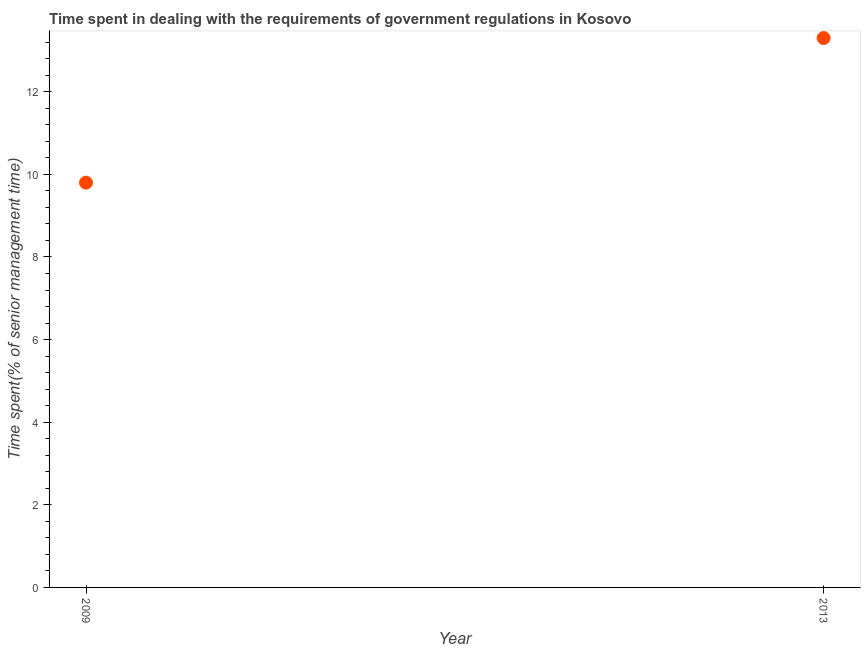Across all years, what is the minimum time spent in dealing with government regulations?
Keep it short and to the point. 9.8. In which year was the time spent in dealing with government regulations maximum?
Provide a succinct answer. 2013. What is the sum of the time spent in dealing with government regulations?
Your response must be concise. 23.1. What is the difference between the time spent in dealing with government regulations in 2009 and 2013?
Ensure brevity in your answer.  -3.5. What is the average time spent in dealing with government regulations per year?
Provide a short and direct response. 11.55. What is the median time spent in dealing with government regulations?
Provide a short and direct response. 11.55. What is the ratio of the time spent in dealing with government regulations in 2009 to that in 2013?
Ensure brevity in your answer.  0.74. Is the time spent in dealing with government regulations in 2009 less than that in 2013?
Offer a very short reply. Yes. How many dotlines are there?
Keep it short and to the point. 1. What is the difference between two consecutive major ticks on the Y-axis?
Offer a very short reply. 2. Are the values on the major ticks of Y-axis written in scientific E-notation?
Your answer should be compact. No. Does the graph contain grids?
Offer a terse response. No. What is the title of the graph?
Ensure brevity in your answer.  Time spent in dealing with the requirements of government regulations in Kosovo. What is the label or title of the Y-axis?
Give a very brief answer. Time spent(% of senior management time). What is the Time spent(% of senior management time) in 2009?
Make the answer very short. 9.8. What is the difference between the Time spent(% of senior management time) in 2009 and 2013?
Your answer should be very brief. -3.5. What is the ratio of the Time spent(% of senior management time) in 2009 to that in 2013?
Make the answer very short. 0.74. 